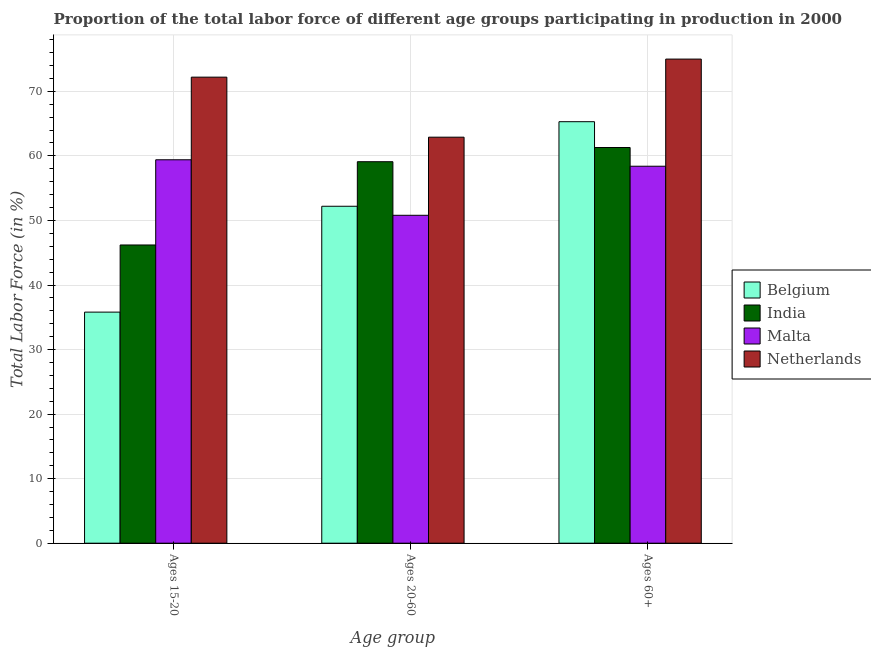How many different coloured bars are there?
Your answer should be very brief. 4. Are the number of bars per tick equal to the number of legend labels?
Make the answer very short. Yes. Are the number of bars on each tick of the X-axis equal?
Offer a very short reply. Yes. How many bars are there on the 2nd tick from the right?
Offer a very short reply. 4. What is the label of the 2nd group of bars from the left?
Give a very brief answer. Ages 20-60. What is the percentage of labor force above age 60 in India?
Make the answer very short. 61.3. Across all countries, what is the maximum percentage of labor force within the age group 20-60?
Make the answer very short. 62.9. Across all countries, what is the minimum percentage of labor force above age 60?
Your response must be concise. 58.4. In which country was the percentage of labor force above age 60 maximum?
Provide a succinct answer. Netherlands. In which country was the percentage of labor force within the age group 15-20 minimum?
Your answer should be compact. Belgium. What is the total percentage of labor force within the age group 20-60 in the graph?
Provide a succinct answer. 225. What is the difference between the percentage of labor force above age 60 in India and that in Belgium?
Your response must be concise. -4. What is the difference between the percentage of labor force within the age group 15-20 in Belgium and the percentage of labor force within the age group 20-60 in Netherlands?
Make the answer very short. -27.1. What is the average percentage of labor force within the age group 20-60 per country?
Your response must be concise. 56.25. What is the difference between the percentage of labor force above age 60 and percentage of labor force within the age group 20-60 in Netherlands?
Provide a short and direct response. 12.1. What is the ratio of the percentage of labor force within the age group 20-60 in India to that in Netherlands?
Your response must be concise. 0.94. Is the percentage of labor force within the age group 20-60 in Malta less than that in Netherlands?
Provide a succinct answer. Yes. What is the difference between the highest and the second highest percentage of labor force within the age group 15-20?
Ensure brevity in your answer.  12.8. What is the difference between the highest and the lowest percentage of labor force within the age group 20-60?
Provide a short and direct response. 12.1. What does the 2nd bar from the right in Ages 20-60 represents?
Offer a terse response. Malta. Is it the case that in every country, the sum of the percentage of labor force within the age group 15-20 and percentage of labor force within the age group 20-60 is greater than the percentage of labor force above age 60?
Ensure brevity in your answer.  Yes. How many bars are there?
Your answer should be compact. 12. Are all the bars in the graph horizontal?
Your answer should be very brief. No. How many countries are there in the graph?
Give a very brief answer. 4. Does the graph contain any zero values?
Give a very brief answer. No. Does the graph contain grids?
Make the answer very short. Yes. Where does the legend appear in the graph?
Your answer should be compact. Center right. How many legend labels are there?
Your answer should be compact. 4. How are the legend labels stacked?
Ensure brevity in your answer.  Vertical. What is the title of the graph?
Provide a succinct answer. Proportion of the total labor force of different age groups participating in production in 2000. What is the label or title of the X-axis?
Your response must be concise. Age group. What is the Total Labor Force (in %) in Belgium in Ages 15-20?
Your answer should be very brief. 35.8. What is the Total Labor Force (in %) in India in Ages 15-20?
Provide a short and direct response. 46.2. What is the Total Labor Force (in %) of Malta in Ages 15-20?
Give a very brief answer. 59.4. What is the Total Labor Force (in %) in Netherlands in Ages 15-20?
Offer a terse response. 72.2. What is the Total Labor Force (in %) in Belgium in Ages 20-60?
Your response must be concise. 52.2. What is the Total Labor Force (in %) of India in Ages 20-60?
Provide a short and direct response. 59.1. What is the Total Labor Force (in %) in Malta in Ages 20-60?
Provide a short and direct response. 50.8. What is the Total Labor Force (in %) in Netherlands in Ages 20-60?
Your answer should be compact. 62.9. What is the Total Labor Force (in %) in Belgium in Ages 60+?
Offer a very short reply. 65.3. What is the Total Labor Force (in %) of India in Ages 60+?
Offer a terse response. 61.3. What is the Total Labor Force (in %) of Malta in Ages 60+?
Your response must be concise. 58.4. Across all Age group, what is the maximum Total Labor Force (in %) of Belgium?
Offer a terse response. 65.3. Across all Age group, what is the maximum Total Labor Force (in %) in India?
Offer a terse response. 61.3. Across all Age group, what is the maximum Total Labor Force (in %) in Malta?
Give a very brief answer. 59.4. Across all Age group, what is the minimum Total Labor Force (in %) of Belgium?
Your answer should be very brief. 35.8. Across all Age group, what is the minimum Total Labor Force (in %) of India?
Your response must be concise. 46.2. Across all Age group, what is the minimum Total Labor Force (in %) in Malta?
Offer a terse response. 50.8. Across all Age group, what is the minimum Total Labor Force (in %) in Netherlands?
Ensure brevity in your answer.  62.9. What is the total Total Labor Force (in %) of Belgium in the graph?
Provide a succinct answer. 153.3. What is the total Total Labor Force (in %) in India in the graph?
Offer a terse response. 166.6. What is the total Total Labor Force (in %) of Malta in the graph?
Give a very brief answer. 168.6. What is the total Total Labor Force (in %) in Netherlands in the graph?
Your answer should be compact. 210.1. What is the difference between the Total Labor Force (in %) of Belgium in Ages 15-20 and that in Ages 20-60?
Your response must be concise. -16.4. What is the difference between the Total Labor Force (in %) in Malta in Ages 15-20 and that in Ages 20-60?
Give a very brief answer. 8.6. What is the difference between the Total Labor Force (in %) in Netherlands in Ages 15-20 and that in Ages 20-60?
Make the answer very short. 9.3. What is the difference between the Total Labor Force (in %) of Belgium in Ages 15-20 and that in Ages 60+?
Your response must be concise. -29.5. What is the difference between the Total Labor Force (in %) of India in Ages 15-20 and that in Ages 60+?
Offer a terse response. -15.1. What is the difference between the Total Labor Force (in %) in Malta in Ages 15-20 and that in Ages 60+?
Keep it short and to the point. 1. What is the difference between the Total Labor Force (in %) of Netherlands in Ages 15-20 and that in Ages 60+?
Your answer should be compact. -2.8. What is the difference between the Total Labor Force (in %) in Netherlands in Ages 20-60 and that in Ages 60+?
Offer a terse response. -12.1. What is the difference between the Total Labor Force (in %) of Belgium in Ages 15-20 and the Total Labor Force (in %) of India in Ages 20-60?
Your response must be concise. -23.3. What is the difference between the Total Labor Force (in %) in Belgium in Ages 15-20 and the Total Labor Force (in %) in Netherlands in Ages 20-60?
Make the answer very short. -27.1. What is the difference between the Total Labor Force (in %) in India in Ages 15-20 and the Total Labor Force (in %) in Netherlands in Ages 20-60?
Give a very brief answer. -16.7. What is the difference between the Total Labor Force (in %) in Belgium in Ages 15-20 and the Total Labor Force (in %) in India in Ages 60+?
Your response must be concise. -25.5. What is the difference between the Total Labor Force (in %) in Belgium in Ages 15-20 and the Total Labor Force (in %) in Malta in Ages 60+?
Your answer should be very brief. -22.6. What is the difference between the Total Labor Force (in %) of Belgium in Ages 15-20 and the Total Labor Force (in %) of Netherlands in Ages 60+?
Offer a very short reply. -39.2. What is the difference between the Total Labor Force (in %) in India in Ages 15-20 and the Total Labor Force (in %) in Malta in Ages 60+?
Your answer should be very brief. -12.2. What is the difference between the Total Labor Force (in %) of India in Ages 15-20 and the Total Labor Force (in %) of Netherlands in Ages 60+?
Keep it short and to the point. -28.8. What is the difference between the Total Labor Force (in %) in Malta in Ages 15-20 and the Total Labor Force (in %) in Netherlands in Ages 60+?
Offer a terse response. -15.6. What is the difference between the Total Labor Force (in %) of Belgium in Ages 20-60 and the Total Labor Force (in %) of Netherlands in Ages 60+?
Ensure brevity in your answer.  -22.8. What is the difference between the Total Labor Force (in %) in India in Ages 20-60 and the Total Labor Force (in %) in Malta in Ages 60+?
Make the answer very short. 0.7. What is the difference between the Total Labor Force (in %) of India in Ages 20-60 and the Total Labor Force (in %) of Netherlands in Ages 60+?
Offer a terse response. -15.9. What is the difference between the Total Labor Force (in %) of Malta in Ages 20-60 and the Total Labor Force (in %) of Netherlands in Ages 60+?
Your answer should be compact. -24.2. What is the average Total Labor Force (in %) in Belgium per Age group?
Provide a succinct answer. 51.1. What is the average Total Labor Force (in %) in India per Age group?
Give a very brief answer. 55.53. What is the average Total Labor Force (in %) of Malta per Age group?
Keep it short and to the point. 56.2. What is the average Total Labor Force (in %) of Netherlands per Age group?
Your answer should be compact. 70.03. What is the difference between the Total Labor Force (in %) of Belgium and Total Labor Force (in %) of India in Ages 15-20?
Your answer should be compact. -10.4. What is the difference between the Total Labor Force (in %) in Belgium and Total Labor Force (in %) in Malta in Ages 15-20?
Provide a succinct answer. -23.6. What is the difference between the Total Labor Force (in %) of Belgium and Total Labor Force (in %) of Netherlands in Ages 15-20?
Offer a terse response. -36.4. What is the difference between the Total Labor Force (in %) of Belgium and Total Labor Force (in %) of Netherlands in Ages 20-60?
Ensure brevity in your answer.  -10.7. What is the difference between the Total Labor Force (in %) of India and Total Labor Force (in %) of Netherlands in Ages 20-60?
Your response must be concise. -3.8. What is the difference between the Total Labor Force (in %) in Belgium and Total Labor Force (in %) in India in Ages 60+?
Keep it short and to the point. 4. What is the difference between the Total Labor Force (in %) in Belgium and Total Labor Force (in %) in Netherlands in Ages 60+?
Make the answer very short. -9.7. What is the difference between the Total Labor Force (in %) in India and Total Labor Force (in %) in Netherlands in Ages 60+?
Make the answer very short. -13.7. What is the difference between the Total Labor Force (in %) in Malta and Total Labor Force (in %) in Netherlands in Ages 60+?
Provide a succinct answer. -16.6. What is the ratio of the Total Labor Force (in %) of Belgium in Ages 15-20 to that in Ages 20-60?
Provide a short and direct response. 0.69. What is the ratio of the Total Labor Force (in %) of India in Ages 15-20 to that in Ages 20-60?
Ensure brevity in your answer.  0.78. What is the ratio of the Total Labor Force (in %) in Malta in Ages 15-20 to that in Ages 20-60?
Make the answer very short. 1.17. What is the ratio of the Total Labor Force (in %) in Netherlands in Ages 15-20 to that in Ages 20-60?
Give a very brief answer. 1.15. What is the ratio of the Total Labor Force (in %) of Belgium in Ages 15-20 to that in Ages 60+?
Offer a very short reply. 0.55. What is the ratio of the Total Labor Force (in %) in India in Ages 15-20 to that in Ages 60+?
Your answer should be compact. 0.75. What is the ratio of the Total Labor Force (in %) in Malta in Ages 15-20 to that in Ages 60+?
Provide a short and direct response. 1.02. What is the ratio of the Total Labor Force (in %) in Netherlands in Ages 15-20 to that in Ages 60+?
Your answer should be compact. 0.96. What is the ratio of the Total Labor Force (in %) of Belgium in Ages 20-60 to that in Ages 60+?
Keep it short and to the point. 0.8. What is the ratio of the Total Labor Force (in %) in India in Ages 20-60 to that in Ages 60+?
Your answer should be very brief. 0.96. What is the ratio of the Total Labor Force (in %) of Malta in Ages 20-60 to that in Ages 60+?
Ensure brevity in your answer.  0.87. What is the ratio of the Total Labor Force (in %) in Netherlands in Ages 20-60 to that in Ages 60+?
Keep it short and to the point. 0.84. What is the difference between the highest and the second highest Total Labor Force (in %) in Belgium?
Provide a short and direct response. 13.1. What is the difference between the highest and the second highest Total Labor Force (in %) in Malta?
Ensure brevity in your answer.  1. What is the difference between the highest and the lowest Total Labor Force (in %) in Belgium?
Offer a terse response. 29.5. What is the difference between the highest and the lowest Total Labor Force (in %) of India?
Offer a very short reply. 15.1. 